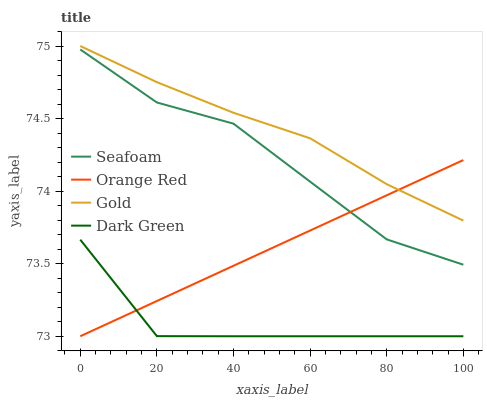Does Dark Green have the minimum area under the curve?
Answer yes or no. Yes. Does Gold have the maximum area under the curve?
Answer yes or no. Yes. Does Seafoam have the minimum area under the curve?
Answer yes or no. No. Does Seafoam have the maximum area under the curve?
Answer yes or no. No. Is Orange Red the smoothest?
Answer yes or no. Yes. Is Seafoam the roughest?
Answer yes or no. Yes. Is Gold the smoothest?
Answer yes or no. No. Is Gold the roughest?
Answer yes or no. No. Does Dark Green have the lowest value?
Answer yes or no. Yes. Does Seafoam have the lowest value?
Answer yes or no. No. Does Gold have the highest value?
Answer yes or no. Yes. Does Seafoam have the highest value?
Answer yes or no. No. Is Dark Green less than Gold?
Answer yes or no. Yes. Is Gold greater than Seafoam?
Answer yes or no. Yes. Does Orange Red intersect Seafoam?
Answer yes or no. Yes. Is Orange Red less than Seafoam?
Answer yes or no. No. Is Orange Red greater than Seafoam?
Answer yes or no. No. Does Dark Green intersect Gold?
Answer yes or no. No. 